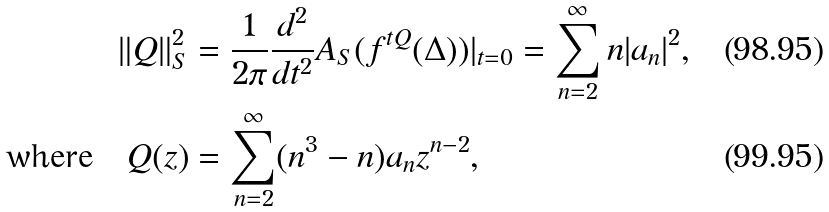Convert formula to latex. <formula><loc_0><loc_0><loc_500><loc_500>\| Q \| _ { S } ^ { 2 } & = \frac { 1 } { 2 \pi } \frac { d ^ { 2 } } { d t ^ { 2 } } A _ { S } ( f ^ { t Q } ( \Delta ) ) | _ { t = 0 } = \sum _ { n = 2 } ^ { \infty } n | a _ { n } | ^ { 2 } , \\ \text {where} \quad Q ( z ) & = \sum _ { n = 2 } ^ { \infty } ( n ^ { 3 } - n ) a _ { n } z ^ { n - 2 } ,</formula> 